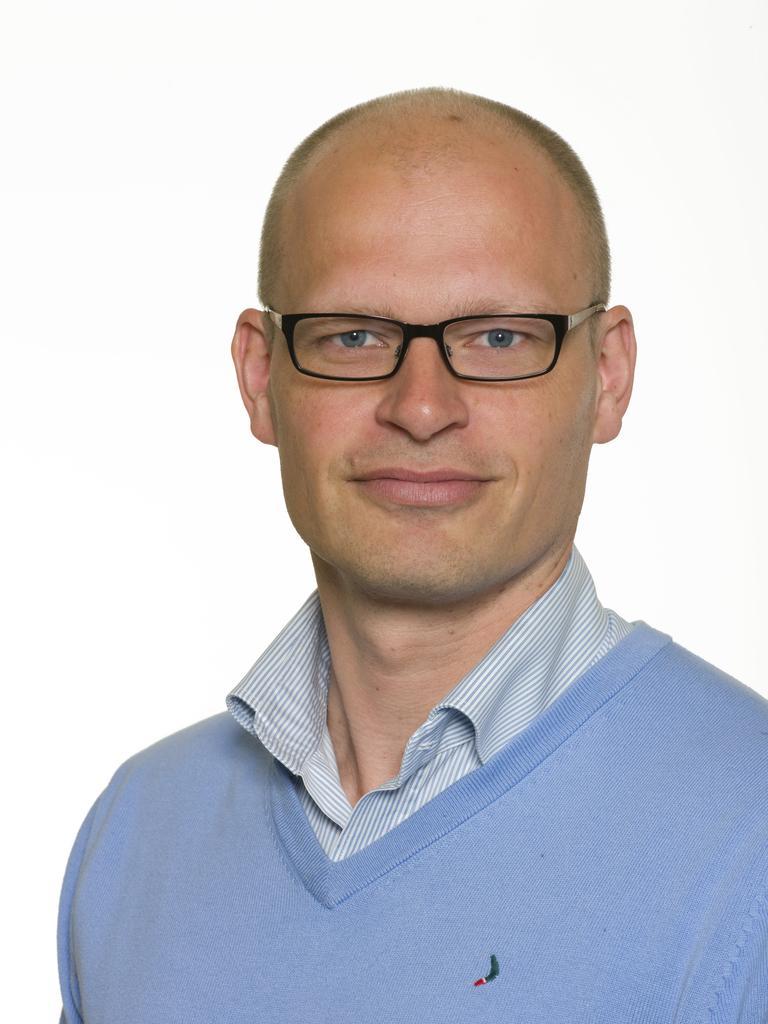In one or two sentences, can you explain what this image depicts? In this image I can see a man wearing a blue t shirt and spectacles. There is a white background. 